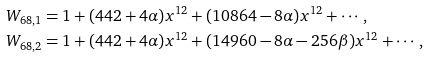<formula> <loc_0><loc_0><loc_500><loc_500>W _ { 6 8 , 1 } & = 1 + ( 4 4 2 + 4 \alpha ) x ^ { 1 2 } + ( 1 0 8 6 4 - 8 \alpha ) x ^ { 1 2 } + \cdots , \\ W _ { 6 8 , 2 } & = 1 + ( 4 4 2 + 4 \alpha ) x ^ { 1 2 } + ( 1 4 9 6 0 - 8 \alpha - 2 5 6 \beta ) x ^ { 1 2 } + \cdots ,</formula> 